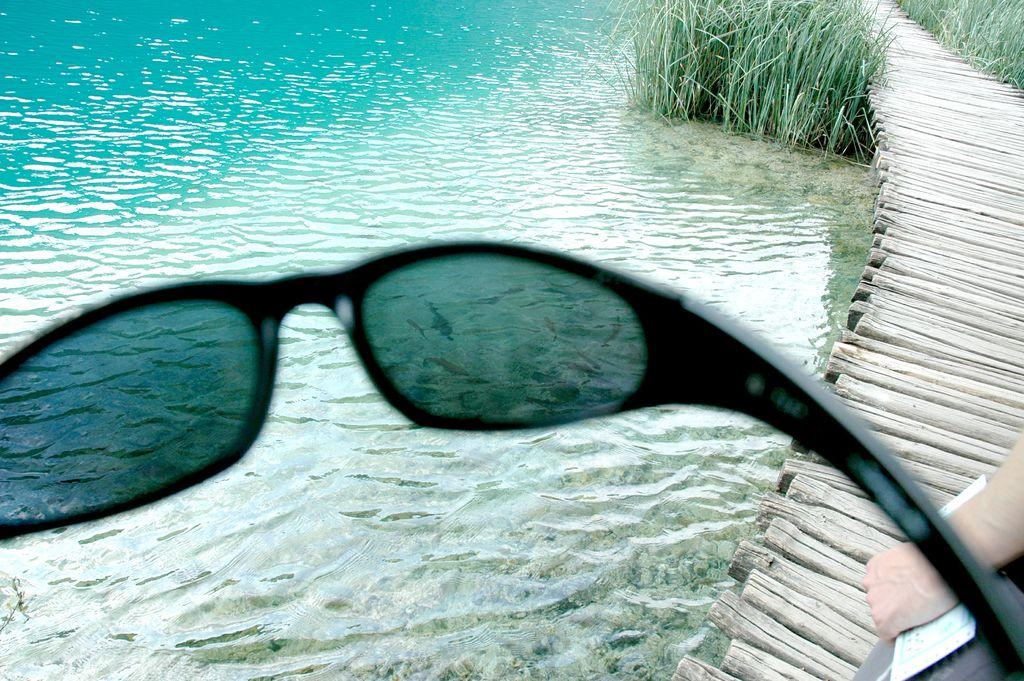What type of eyewear is present in the image? There are black colored goggles in the image. What is the person in the image doing with an object? A person's hand is holding an object in the image. What can be seen in the background of the image? There is water, grass, and a wooden path visible in the background of the image. What type of hat is the person wearing in the image? There is no hat visible in the image; the person is holding an object with their hand. How many buttons can be seen on the goggles in the image? The goggles in the image do not have buttons, as they are a single piece of eyewear. 